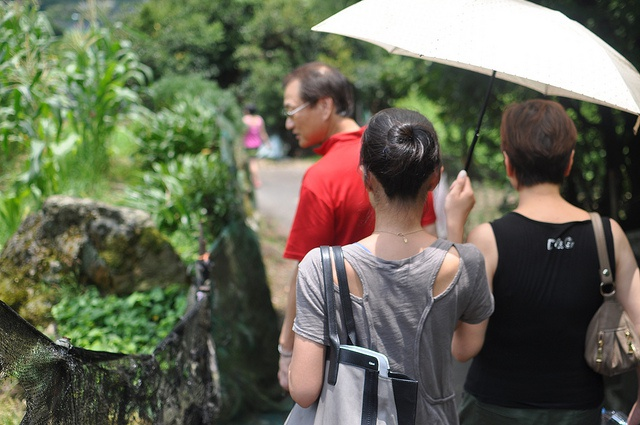Describe the objects in this image and their specific colors. I can see people in gray, black, darkgray, and lightgray tones, people in gray, black, and tan tones, umbrella in gray, white, darkgray, lightgray, and tan tones, people in gray, brown, salmon, and maroon tones, and handbag in gray, black, darkgray, and lightgray tones in this image. 